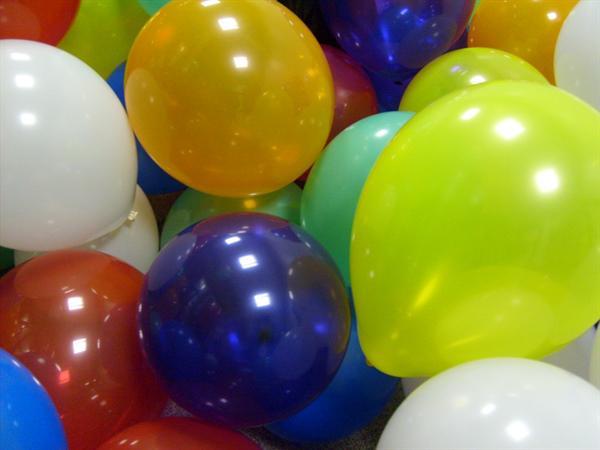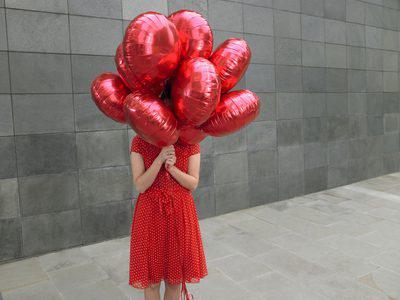The first image is the image on the left, the second image is the image on the right. Given the left and right images, does the statement "One person whose face cannot be seen is holding at least one balloon." hold true? Answer yes or no. Yes. 